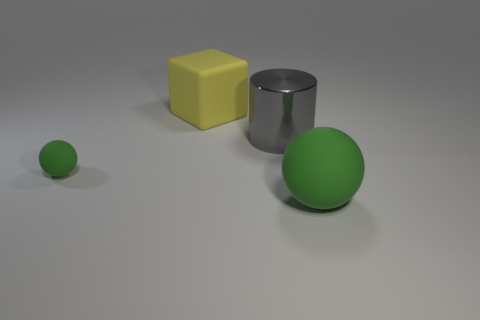Is the material of the large cube the same as the big cylinder?
Offer a very short reply. No. Are there the same number of large things behind the gray thing and tiny green balls that are to the right of the small sphere?
Provide a short and direct response. No. What number of small green spheres are in front of the big gray cylinder?
Make the answer very short. 1. How many objects are either matte spheres or large yellow rubber objects?
Provide a short and direct response. 3. How many red balls are the same size as the yellow object?
Ensure brevity in your answer.  0. There is a green thing that is left of the green thing that is in front of the tiny green matte thing; what shape is it?
Offer a terse response. Sphere. Are there fewer small yellow rubber objects than gray shiny things?
Your answer should be very brief. Yes. The sphere behind the big green matte ball is what color?
Your answer should be compact. Green. There is a big thing that is both in front of the yellow matte block and behind the tiny green ball; what is its material?
Your answer should be compact. Metal. There is a big green thing that is made of the same material as the big cube; what shape is it?
Give a very brief answer. Sphere. 